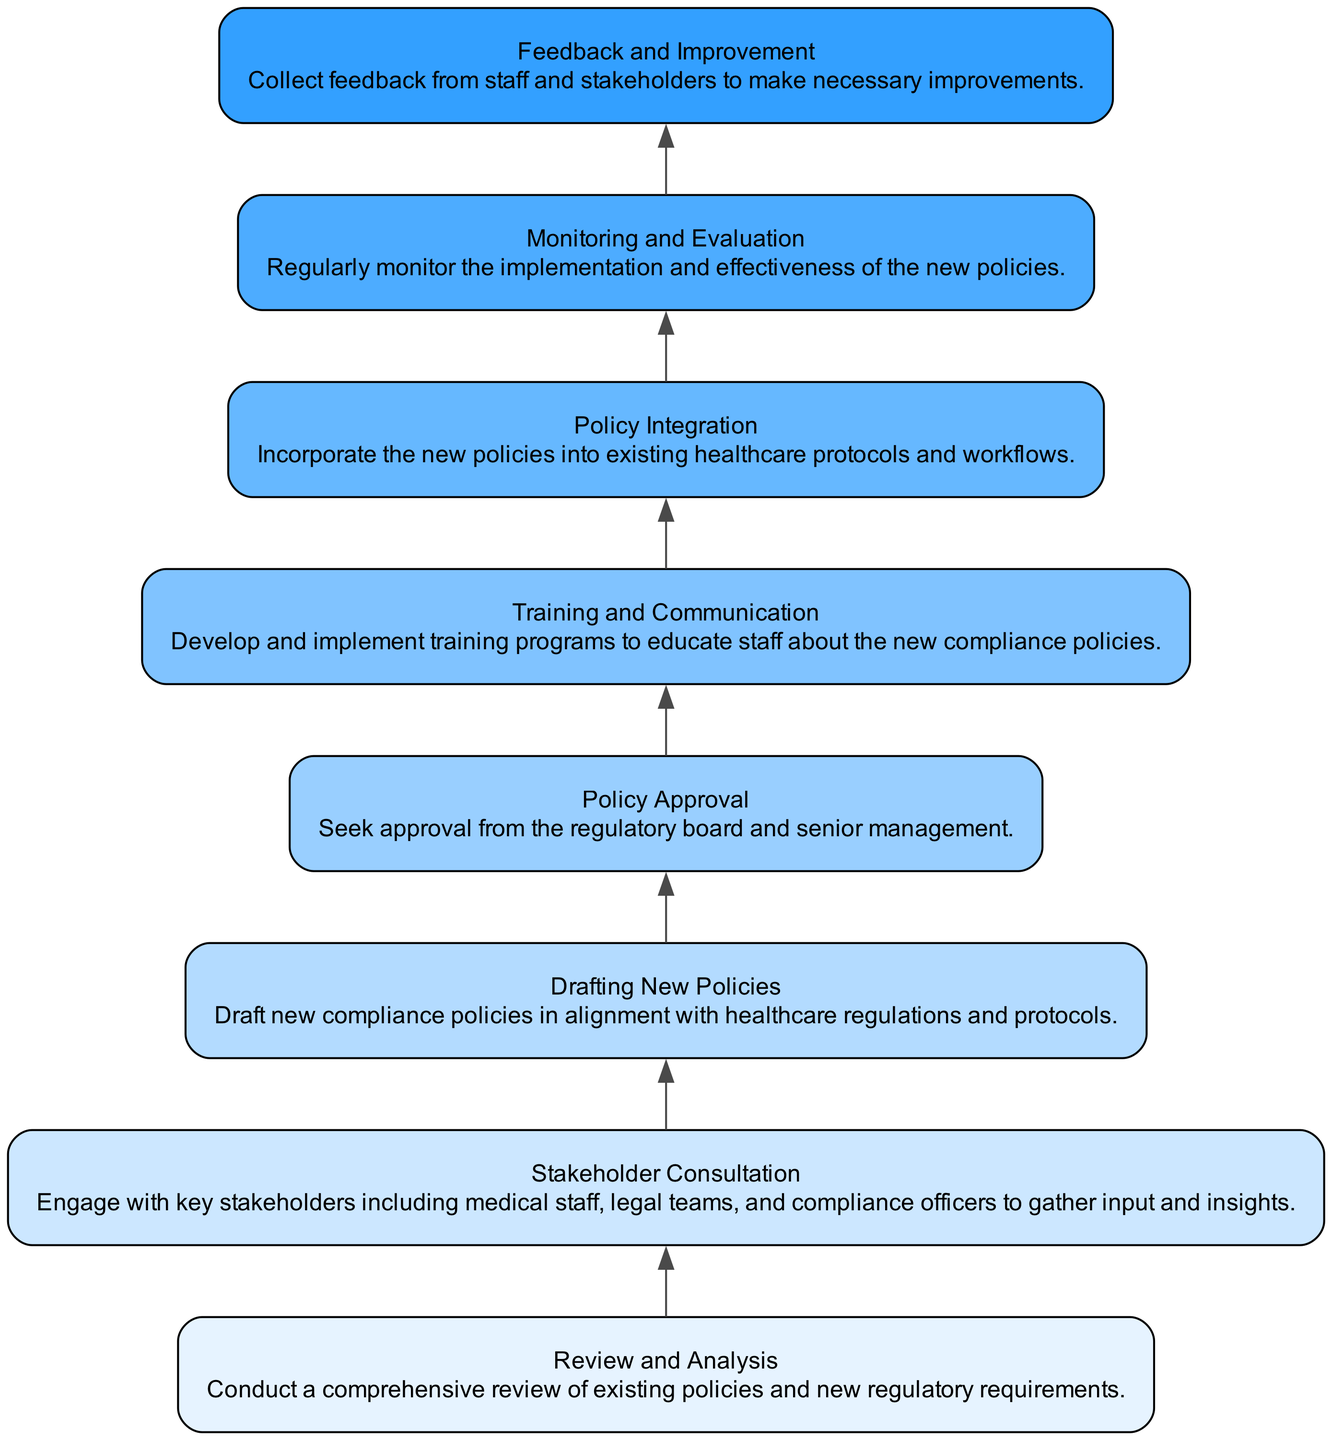What is the first step in the implementation process? The first step is always the bottom-most node in the flow chart. According to the diagram, it starts with "Review and Analysis."
Answer: Review and Analysis How many nodes are in the diagram? To find the total number of nodes, we count each unique step present in the flow chart. The diagram shows eight distinct steps or nodes.
Answer: Eight What follows "Policy Approval" in the process? By examining the direction of the flow from bottom to up, we see that "Policy Approval" leads to "Training and Communication."
Answer: Training and Communication Which step involves collecting feedback for improvements? The final step in the flow, as indicated by the upward direction, is the last node labeled "Feedback and Improvement."
Answer: Feedback and Improvement What is the relationship between "Stakeholder Consultation" and "Drafting New Policies"? Observing the edges connecting the nodes, "Stakeholder Consultation" is directly linked to "Drafting New Policies" as it precedes it in the implementation sequence.
Answer: Precedes What are the last two steps in the implementation process? The last two nodes in the flow chart, moving upward from the bottom, are "Monitoring and Evaluation" and "Feedback and Improvement," indicating their sequential relationship at the end of the process.
Answer: Monitoring and Evaluation, Feedback and Improvement Which step is specifically aimed at training staff? In the flow chart, the step that focuses on training is labeled "Training and Communication," making it explicit that staff education is part of the compliance implementation.
Answer: Training and Communication How do the steps relate to regulatory compliance? Each step in the flow chart is designed to build on compliance with healthcare regulations, starting from the review process and moving through policy drafting, approval, and stakeholder feedback to ensure adherence to outlined regulations.
Answer: Sequential compliance structure 